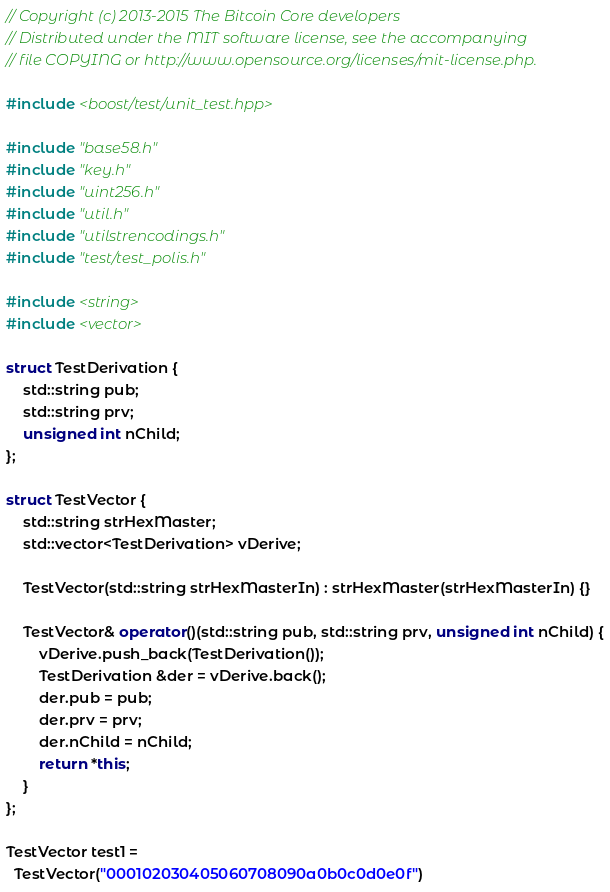<code> <loc_0><loc_0><loc_500><loc_500><_C++_>// Copyright (c) 2013-2015 The Bitcoin Core developers
// Distributed under the MIT software license, see the accompanying
// file COPYING or http://www.opensource.org/licenses/mit-license.php.

#include <boost/test/unit_test.hpp>

#include "base58.h"
#include "key.h"
#include "uint256.h"
#include "util.h"
#include "utilstrencodings.h"
#include "test/test_polis.h"

#include <string>
#include <vector>

struct TestDerivation {
    std::string pub;
    std::string prv;
    unsigned int nChild;
};

struct TestVector {
    std::string strHexMaster;
    std::vector<TestDerivation> vDerive;

    TestVector(std::string strHexMasterIn) : strHexMaster(strHexMasterIn) {}

    TestVector& operator()(std::string pub, std::string prv, unsigned int nChild) {
        vDerive.push_back(TestDerivation());
        TestDerivation &der = vDerive.back();
        der.pub = pub;
        der.prv = prv;
        der.nChild = nChild;
        return *this;
    }
};

TestVector test1 =
  TestVector("000102030405060708090a0b0c0d0e0f")</code> 